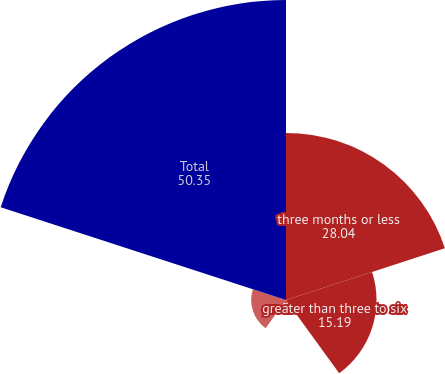Convert chart to OTSL. <chart><loc_0><loc_0><loc_500><loc_500><pie_chart><fcel>three months or less<fcel>greater than three to six<fcel>greater than six to nine<fcel>twelve months or more<fcel>Total<nl><fcel>28.04%<fcel>15.19%<fcel>0.58%<fcel>5.84%<fcel>50.35%<nl></chart> 